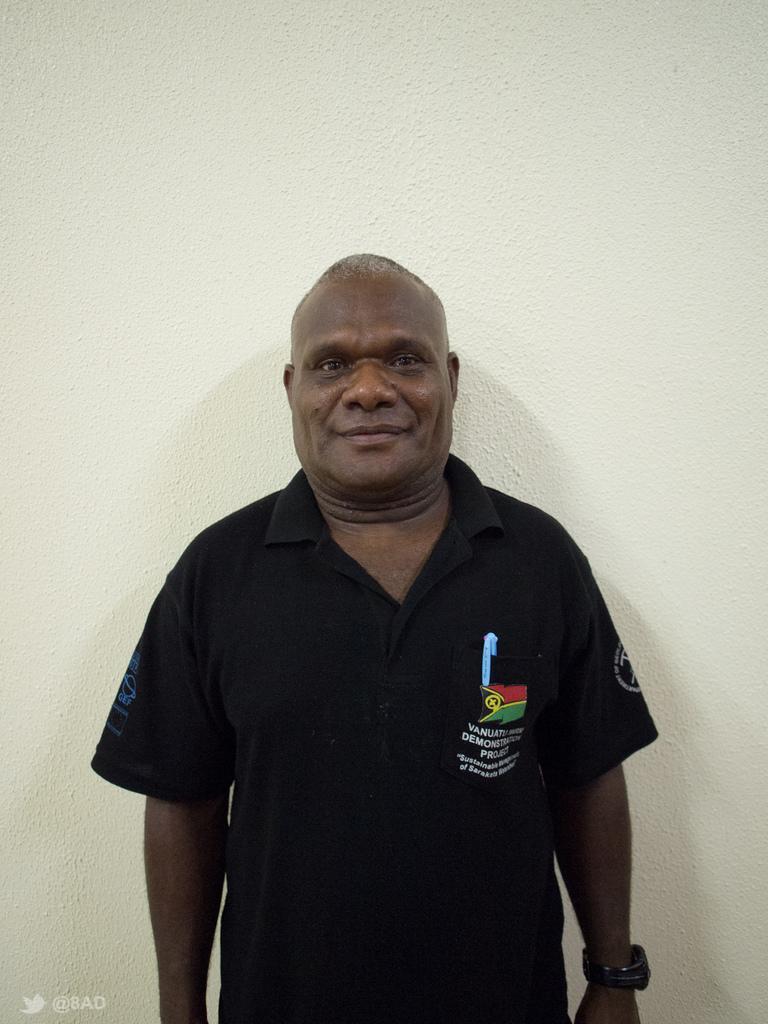Could you give a brief overview of what you see in this image? In this image I can see the person standing and the person is wearing black color dress and I can see the white color background. 